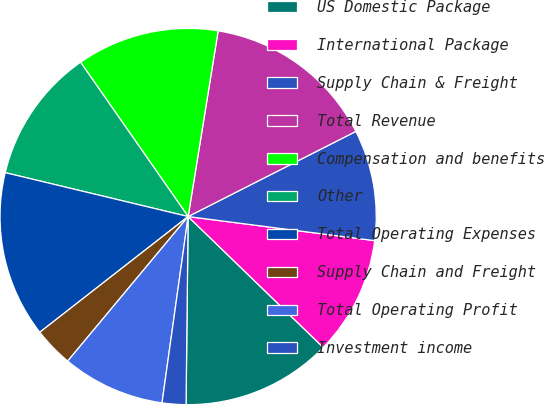<chart> <loc_0><loc_0><loc_500><loc_500><pie_chart><fcel>US Domestic Package<fcel>International Package<fcel>Supply Chain & Freight<fcel>Total Revenue<fcel>Compensation and benefits<fcel>Other<fcel>Total Operating Expenses<fcel>Supply Chain and Freight<fcel>Total Operating Profit<fcel>Investment income<nl><fcel>12.93%<fcel>10.2%<fcel>9.52%<fcel>14.97%<fcel>12.24%<fcel>11.56%<fcel>14.29%<fcel>3.4%<fcel>8.84%<fcel>2.04%<nl></chart> 